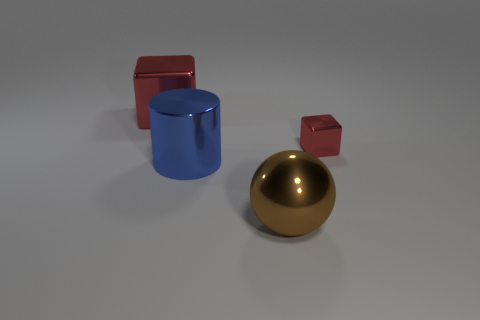Are there any objects in the image that are reflective? Yes, the sphere in the image has a reflective gold surface, indicating it's likely a metallic material. 